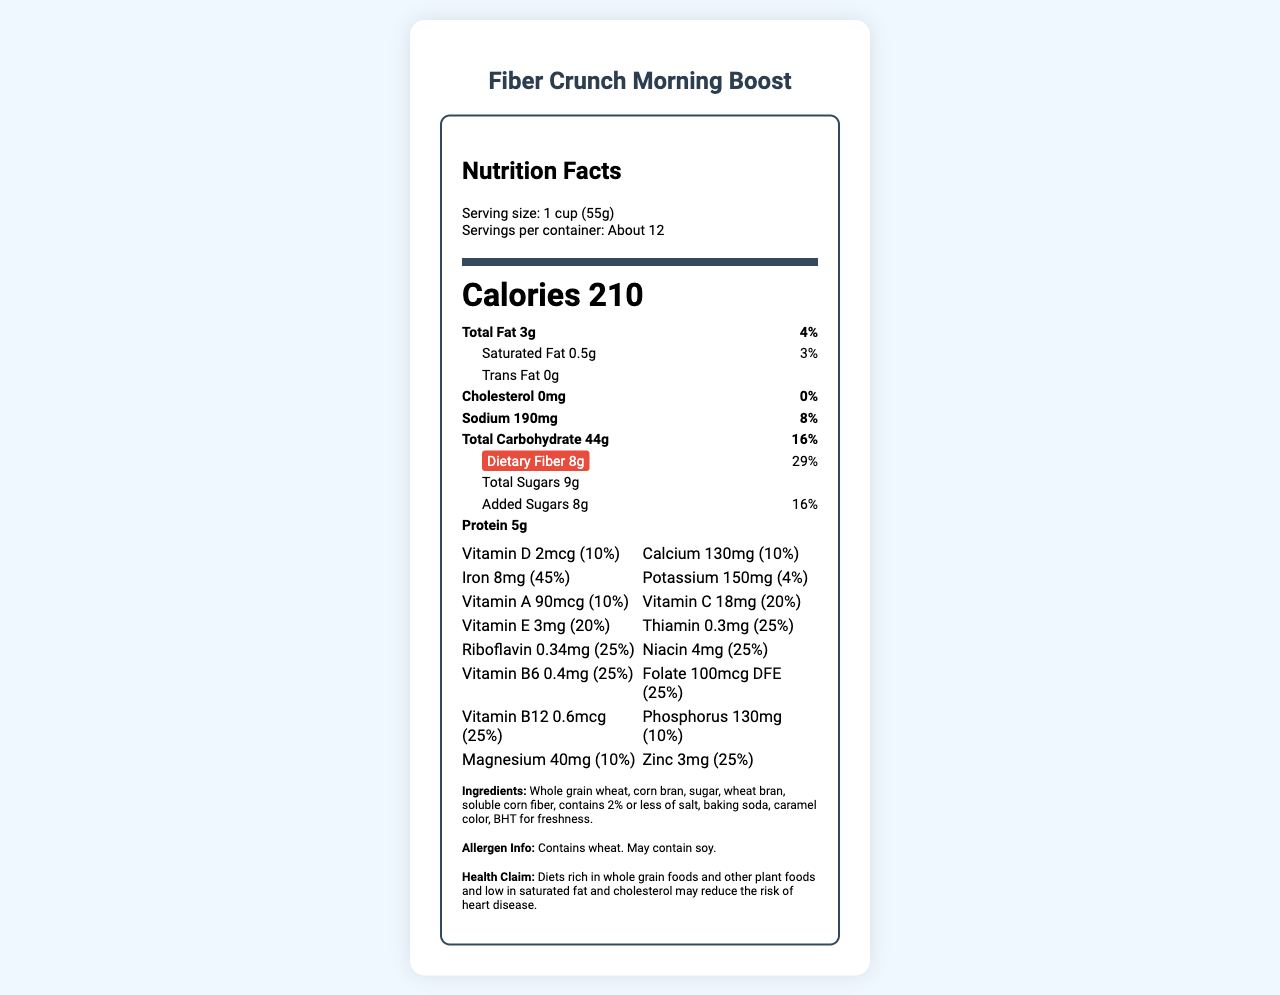what is the serving size of Fiber Crunch Morning Boost? The serving size is mentioned right after the product name under the “Serving size” label, which states "1 cup (55g)".
Answer: 1 cup (55g) what is the amount of dietary fiber per serving? The amount of dietary fiber per serving is listed under "Dietary Fiber" in the "Total Carbohydrate" section, showing "8g".
Answer: 8g what percentage of the daily value of iron does one serving provide? The percentage of the daily value of iron is found under the vitamins section, stating "Iron 8mg (45%)".
Answer: 45% how many calories does one serving contain? The number of calories is prominently displayed in large font as "Calories 210".
Answer: 210 calories how much added sugar is in one serving? The amount of added sugars is detailed under "Added Sugars", which shows "8g".
Answer: 8g how many servings are approximately in one container? The servings per container are listed in the serving info as "About 12".
Answer: About 12 what is the total fat content per serving? The total fat content is found in the "Total Fat" section, showing "3g".
Answer: 3g which vitamin provides the highest percentage of daily value per serving? A. Vitamin D B. Vitamin C C. Vitamin B12 D. Iron Based on the daily values provided, Iron is listed as "Iron 8mg (45%)", which is the highest percentage among all the vitamins and minerals.
Answer: D. Iron how much protein does one serving contain? The protein content is listed in the major nutrients section, showing "Protein 5g".
Answer: 5g does the product contain any allergens? The allergen information at the bottom of the label states: "Contains wheat. May contain soy."
Answer: Yes describe the main idea of the document The document is presented as a nutrition facts label with comprehensive nutritional data and ingredient information.
Answer: The document provides detailed nutrition information for the breakfast cereal "Fiber Crunch Morning Boost". It includes data on serving size, calories, fat content, fiber, sugars, protein, vitamins, and minerals, as well as ingredients, allergen info, and a health claim. is there any trans fat in this product? The trans fat content is listed as "Trans Fat 0g", indicating there is no trans fat.
Answer: No how much vitamin A is provided per serving? A. 90mcg B. 100mg C. 45% D. 130mcg The vitamins section specifies "Vitamin A 90mcg (10%)".
Answer: A. 90mcg what health claim is made about this product? The health claim is provided at the bottom of the document, bolded and stated as: "Diets rich in whole grain foods and other plant foods and low in saturated fat and cholesterol may reduce the risk of heart disease."
Answer: Diets rich in whole grain foods and other plant foods and low in saturated fat and cholesterol may reduce the risk of heart disease. what type of colorant is used in this product? The ingredient list mentions "caramel color" as one of the components.
Answer: Caramel color what is the source of magnesium in this product? The document does not provide specific information on the source of magnesium.
Answer: Not enough information 